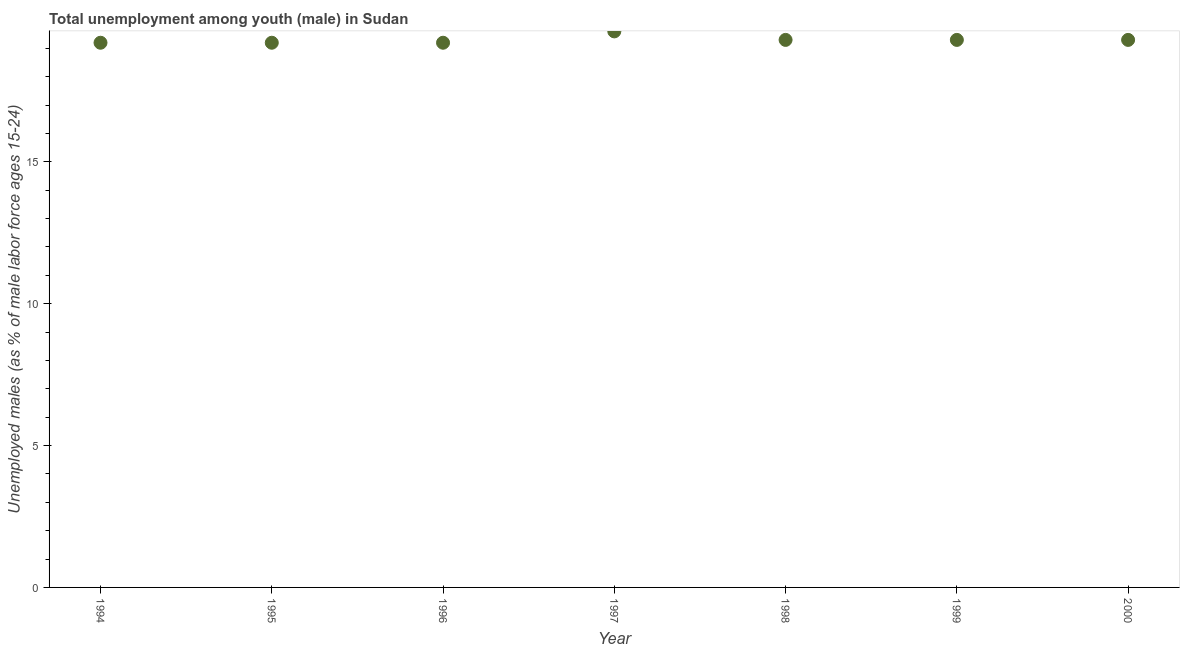What is the unemployed male youth population in 2000?
Your response must be concise. 19.3. Across all years, what is the maximum unemployed male youth population?
Your answer should be compact. 19.6. Across all years, what is the minimum unemployed male youth population?
Your answer should be compact. 19.2. In which year was the unemployed male youth population maximum?
Provide a short and direct response. 1997. What is the sum of the unemployed male youth population?
Give a very brief answer. 135.1. What is the difference between the unemployed male youth population in 1995 and 1998?
Your answer should be very brief. -0.1. What is the average unemployed male youth population per year?
Ensure brevity in your answer.  19.3. What is the median unemployed male youth population?
Make the answer very short. 19.3. Do a majority of the years between 1997 and 1995 (inclusive) have unemployed male youth population greater than 14 %?
Provide a short and direct response. No. What is the ratio of the unemployed male youth population in 1994 to that in 1999?
Provide a short and direct response. 0.99. What is the difference between the highest and the second highest unemployed male youth population?
Your answer should be compact. 0.3. Is the sum of the unemployed male youth population in 1997 and 1998 greater than the maximum unemployed male youth population across all years?
Offer a very short reply. Yes. What is the difference between the highest and the lowest unemployed male youth population?
Offer a very short reply. 0.4. Does the unemployed male youth population monotonically increase over the years?
Your answer should be compact. No. How many years are there in the graph?
Your answer should be compact. 7. Are the values on the major ticks of Y-axis written in scientific E-notation?
Offer a terse response. No. Does the graph contain any zero values?
Your response must be concise. No. What is the title of the graph?
Offer a very short reply. Total unemployment among youth (male) in Sudan. What is the label or title of the X-axis?
Make the answer very short. Year. What is the label or title of the Y-axis?
Keep it short and to the point. Unemployed males (as % of male labor force ages 15-24). What is the Unemployed males (as % of male labor force ages 15-24) in 1994?
Provide a succinct answer. 19.2. What is the Unemployed males (as % of male labor force ages 15-24) in 1995?
Offer a very short reply. 19.2. What is the Unemployed males (as % of male labor force ages 15-24) in 1996?
Give a very brief answer. 19.2. What is the Unemployed males (as % of male labor force ages 15-24) in 1997?
Give a very brief answer. 19.6. What is the Unemployed males (as % of male labor force ages 15-24) in 1998?
Offer a terse response. 19.3. What is the Unemployed males (as % of male labor force ages 15-24) in 1999?
Your answer should be compact. 19.3. What is the Unemployed males (as % of male labor force ages 15-24) in 2000?
Give a very brief answer. 19.3. What is the difference between the Unemployed males (as % of male labor force ages 15-24) in 1994 and 1998?
Your answer should be very brief. -0.1. What is the difference between the Unemployed males (as % of male labor force ages 15-24) in 1994 and 2000?
Keep it short and to the point. -0.1. What is the difference between the Unemployed males (as % of male labor force ages 15-24) in 1995 and 1999?
Make the answer very short. -0.1. What is the difference between the Unemployed males (as % of male labor force ages 15-24) in 1996 and 2000?
Make the answer very short. -0.1. What is the difference between the Unemployed males (as % of male labor force ages 15-24) in 1997 and 1998?
Your answer should be compact. 0.3. What is the difference between the Unemployed males (as % of male labor force ages 15-24) in 1997 and 1999?
Offer a terse response. 0.3. What is the difference between the Unemployed males (as % of male labor force ages 15-24) in 1998 and 2000?
Give a very brief answer. 0. What is the ratio of the Unemployed males (as % of male labor force ages 15-24) in 1994 to that in 1995?
Ensure brevity in your answer.  1. What is the ratio of the Unemployed males (as % of male labor force ages 15-24) in 1994 to that in 1998?
Offer a terse response. 0.99. What is the ratio of the Unemployed males (as % of male labor force ages 15-24) in 1994 to that in 2000?
Give a very brief answer. 0.99. What is the ratio of the Unemployed males (as % of male labor force ages 15-24) in 1995 to that in 1996?
Make the answer very short. 1. What is the ratio of the Unemployed males (as % of male labor force ages 15-24) in 1995 to that in 1998?
Provide a succinct answer. 0.99. What is the ratio of the Unemployed males (as % of male labor force ages 15-24) in 1995 to that in 1999?
Offer a very short reply. 0.99. What is the ratio of the Unemployed males (as % of male labor force ages 15-24) in 1995 to that in 2000?
Provide a short and direct response. 0.99. What is the ratio of the Unemployed males (as % of male labor force ages 15-24) in 1996 to that in 1997?
Provide a short and direct response. 0.98. What is the ratio of the Unemployed males (as % of male labor force ages 15-24) in 1996 to that in 1998?
Offer a terse response. 0.99. What is the ratio of the Unemployed males (as % of male labor force ages 15-24) in 1996 to that in 2000?
Provide a short and direct response. 0.99. What is the ratio of the Unemployed males (as % of male labor force ages 15-24) in 1998 to that in 1999?
Offer a terse response. 1. 